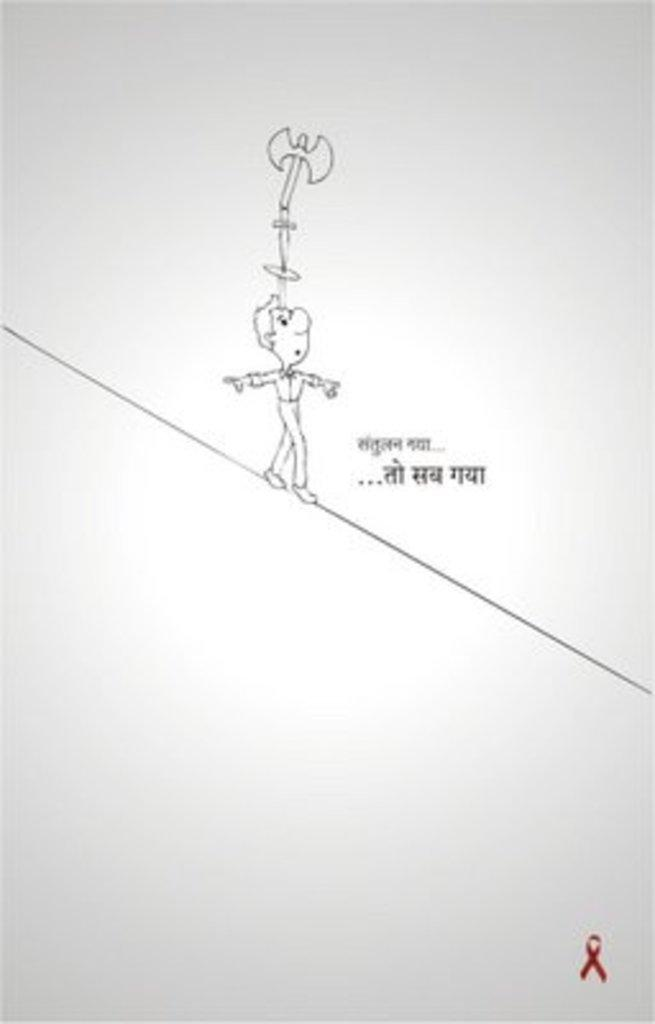What is featured in the image? There is a poster in the image. What type of content is on the poster? The poster contains art. Are there any words on the poster? Yes, there is text on the poster. Can you see an airplane flying in the middle of the poster? There is no airplane present in the image, and the poster does not depict any flying objects. How many ducks are swimming in the text on the poster? There are no ducks depicted in the image, let alone in the text on the poster. 